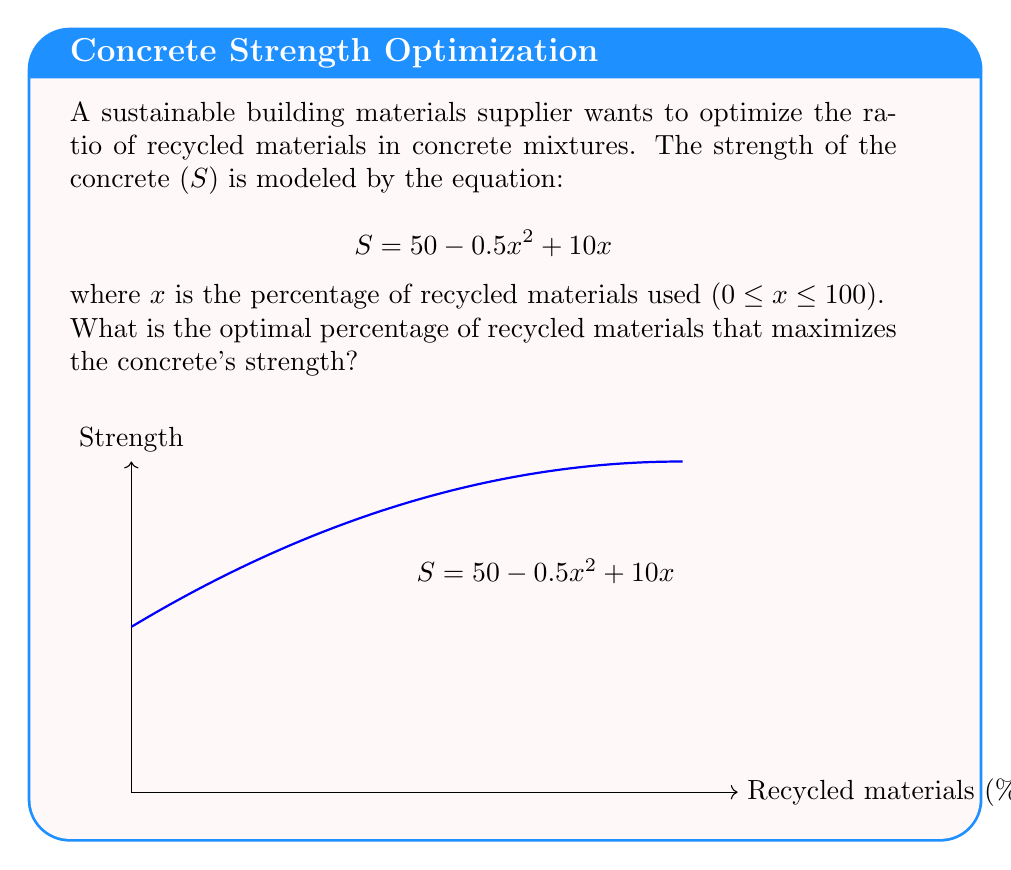Provide a solution to this math problem. To find the optimal percentage of recycled materials, we need to maximize the strength function S(x).

1) First, we find the derivative of S with respect to x:
   $$\frac{dS}{dx} = -x + 10$$

2) To find the maximum, we set the derivative equal to zero and solve for x:
   $$-x + 10 = 0$$
   $$x = 10$$

3) To confirm this is a maximum (not a minimum), we check the second derivative:
   $$\frac{d^2S}{dx^2} = -1$$
   Since this is negative, we confirm that x = 10 gives a maximum.

4) We verify that this falls within the valid range (0 ≤ x ≤ 100).

5) Calculate the strength at x = 10:
   $$S(10) = 50 - 0.5(10)^2 + 10(10) = 50 - 50 + 100 = 100$$

Therefore, the optimal percentage of recycled materials is 10%, which yields a maximum strength of 100 units.
Answer: 10% 